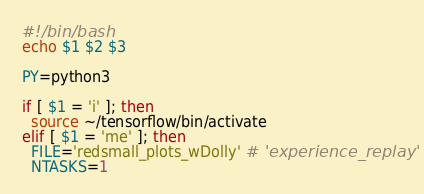Convert code to text. <code><loc_0><loc_0><loc_500><loc_500><_Bash_>#!/bin/bash
echo $1 $2 $3

PY=python3

if [ $1 = 'i' ]; then
  source ~/tensorflow/bin/activate
elif [ $1 = 'me' ]; then
  FILE='redsmall_plots_wDolly' # 'experience_replay'
  NTASKS=1</code> 